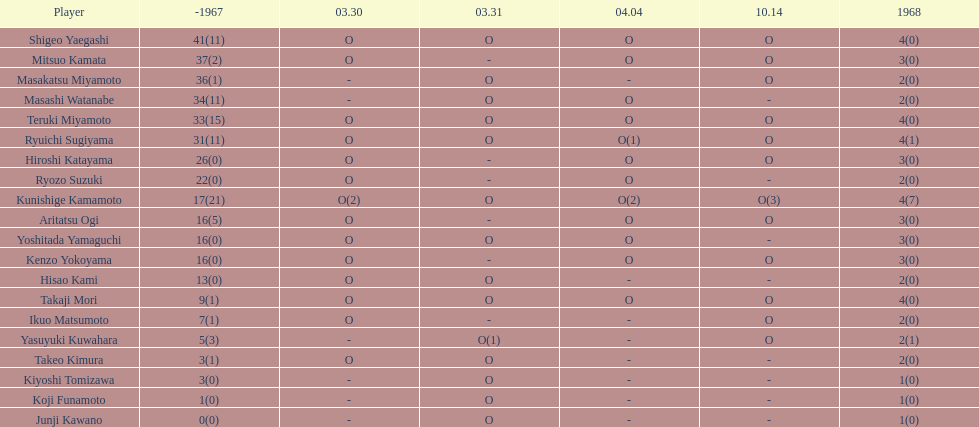Total appearances by masakatsu miyamoto? 38. 